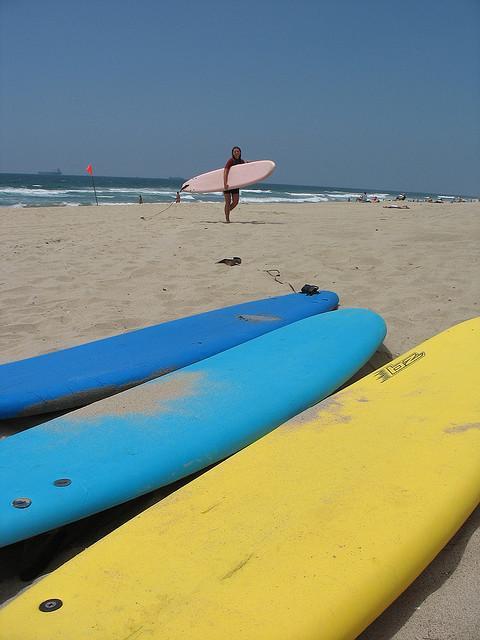Which music group would be able to use all of these boards without sharing?
Select the correct answer and articulate reasoning with the following format: 'Answer: answer
Rationale: rationale.'
Options: Cream, nsync, backstreet boys, spice girls. Answer: cream.
Rationale: The group is cream. 